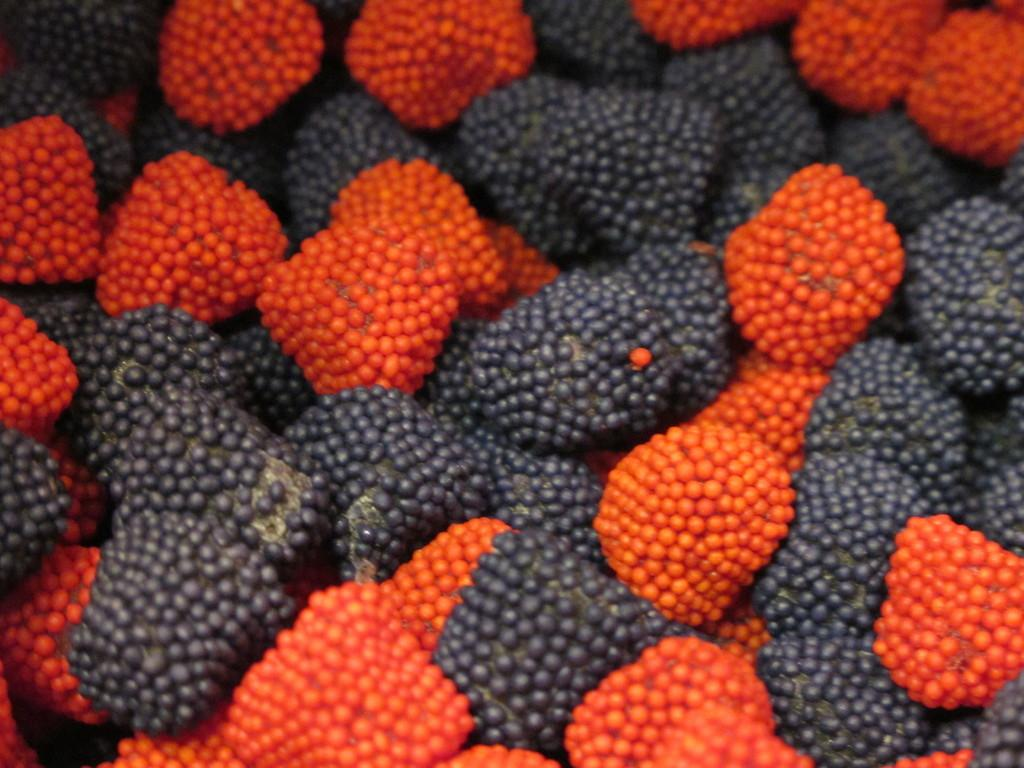What type of fruit is present in the image? There are berries in the image. Can you describe the colors of the berries? The berries are black and red in color. What type of shoes are visible in the image? There are no shoes present in the image; it only features berries. How hot is the temperature in the image? The temperature is not mentioned in the image, as it only contains berries. 